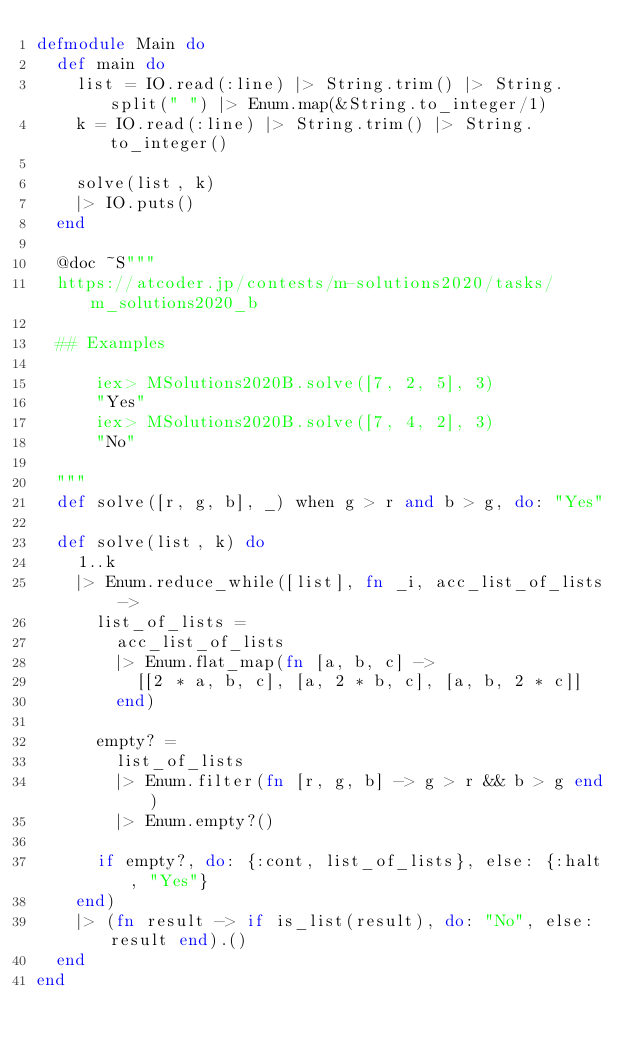<code> <loc_0><loc_0><loc_500><loc_500><_Elixir_>defmodule Main do
  def main do
    list = IO.read(:line) |> String.trim() |> String.split(" ") |> Enum.map(&String.to_integer/1)
    k = IO.read(:line) |> String.trim() |> String.to_integer()

    solve(list, k)
    |> IO.puts()
  end

  @doc ~S"""
  https://atcoder.jp/contests/m-solutions2020/tasks/m_solutions2020_b

  ## Examples

      iex> MSolutions2020B.solve([7, 2, 5], 3)
      "Yes"
      iex> MSolutions2020B.solve([7, 4, 2], 3)
      "No"

  """
  def solve([r, g, b], _) when g > r and b > g, do: "Yes"

  def solve(list, k) do
    1..k
    |> Enum.reduce_while([list], fn _i, acc_list_of_lists ->
      list_of_lists =
        acc_list_of_lists
        |> Enum.flat_map(fn [a, b, c] ->
          [[2 * a, b, c], [a, 2 * b, c], [a, b, 2 * c]]
        end)

      empty? =
        list_of_lists
        |> Enum.filter(fn [r, g, b] -> g > r && b > g end)
        |> Enum.empty?()

      if empty?, do: {:cont, list_of_lists}, else: {:halt, "Yes"}
    end)
    |> (fn result -> if is_list(result), do: "No", else: result end).()
  end
end</code> 